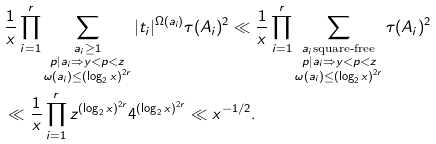Convert formula to latex. <formula><loc_0><loc_0><loc_500><loc_500>& \frac { 1 } { x } \prod _ { i = 1 } ^ { r } \sum _ { \substack { a _ { i } \geq 1 \\ p | a _ { i } \Rightarrow y < p < z \\ \omega ( a _ { i } ) \leq ( \log _ { 2 } x ) ^ { 2 r } } } | t _ { i } | ^ { \Omega ( a _ { i } ) } \tau ( A _ { i } ) ^ { 2 } \ll \frac { 1 } { x } \prod _ { i = 1 } ^ { r } \sum _ { \substack { a _ { i } \text {square-free} \\ p | a _ { i } \Rightarrow y < p < z \\ \omega ( a _ { i } ) \leq ( \log _ { 2 } x ) ^ { 2 r } } } \tau ( A _ { i } ) ^ { 2 } \\ & \ll \frac { 1 } { x } \prod _ { i = 1 } ^ { r } z ^ { ( \log _ { 2 } x ) ^ { 2 r } } 4 ^ { ( \log _ { 2 } x ) ^ { 2 r } } \ll x ^ { - 1 / 2 } .</formula> 